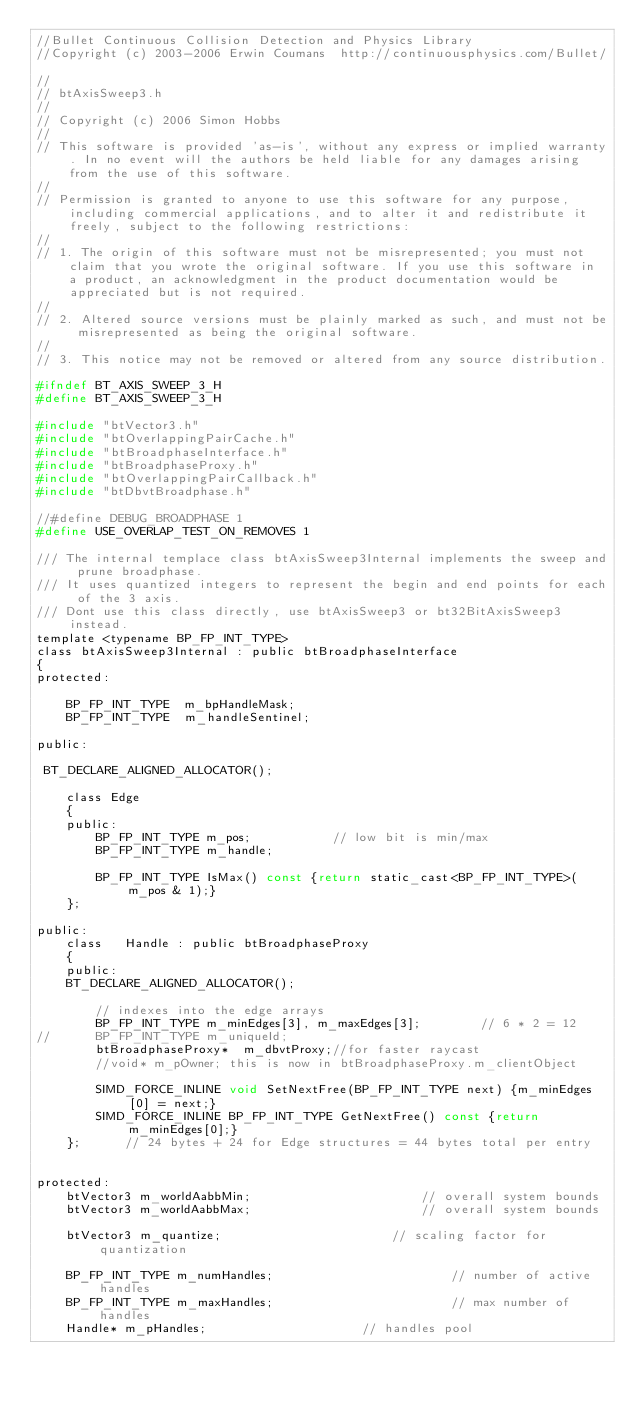<code> <loc_0><loc_0><loc_500><loc_500><_C_>//Bullet Continuous Collision Detection and Physics Library
//Copyright (c) 2003-2006 Erwin Coumans  http://continuousphysics.com/Bullet/

//
// btAxisSweep3.h
//
// Copyright (c) 2006 Simon Hobbs
//
// This software is provided 'as-is', without any express or implied warranty. In no event will the authors be held liable for any damages arising from the use of this software.
//
// Permission is granted to anyone to use this software for any purpose, including commercial applications, and to alter it and redistribute it freely, subject to the following restrictions:
//
// 1. The origin of this software must not be misrepresented; you must not claim that you wrote the original software. If you use this software in a product, an acknowledgment in the product documentation would be appreciated but is not required.
//
// 2. Altered source versions must be plainly marked as such, and must not be misrepresented as being the original software.
//
// 3. This notice may not be removed or altered from any source distribution.

#ifndef BT_AXIS_SWEEP_3_H
#define BT_AXIS_SWEEP_3_H

#include "btVector3.h"
#include "btOverlappingPairCache.h"
#include "btBroadphaseInterface.h"
#include "btBroadphaseProxy.h"
#include "btOverlappingPairCallback.h"
#include "btDbvtBroadphase.h"

//#define DEBUG_BROADPHASE 1
#define USE_OVERLAP_TEST_ON_REMOVES 1

/// The internal templace class btAxisSweep3Internal implements the sweep and prune broadphase.
/// It uses quantized integers to represent the begin and end points for each of the 3 axis.
/// Dont use this class directly, use btAxisSweep3 or bt32BitAxisSweep3 instead.
template <typename BP_FP_INT_TYPE>
class btAxisSweep3Internal : public btBroadphaseInterface
{
protected:

	BP_FP_INT_TYPE	m_bpHandleMask;
	BP_FP_INT_TYPE	m_handleSentinel;

public:
	
 BT_DECLARE_ALIGNED_ALLOCATOR();

	class Edge
	{
	public:
		BP_FP_INT_TYPE m_pos;			// low bit is min/max
		BP_FP_INT_TYPE m_handle;

		BP_FP_INT_TYPE IsMax() const {return static_cast<BP_FP_INT_TYPE>(m_pos & 1);}
	};

public:
	class	Handle : public btBroadphaseProxy
	{
	public:
	BT_DECLARE_ALIGNED_ALLOCATOR();
	
		// indexes into the edge arrays
		BP_FP_INT_TYPE m_minEdges[3], m_maxEdges[3];		// 6 * 2 = 12
//		BP_FP_INT_TYPE m_uniqueId;
		btBroadphaseProxy*	m_dbvtProxy;//for faster raycast
		//void* m_pOwner; this is now in btBroadphaseProxy.m_clientObject
	
		SIMD_FORCE_INLINE void SetNextFree(BP_FP_INT_TYPE next) {m_minEdges[0] = next;}
		SIMD_FORCE_INLINE BP_FP_INT_TYPE GetNextFree() const {return m_minEdges[0];}
	};		// 24 bytes + 24 for Edge structures = 44 bytes total per entry

	
protected:
	btVector3 m_worldAabbMin;						// overall system bounds
	btVector3 m_worldAabbMax;						// overall system bounds

	btVector3 m_quantize;						// scaling factor for quantization

	BP_FP_INT_TYPE m_numHandles;						// number of active handles
	BP_FP_INT_TYPE m_maxHandles;						// max number of handles
	Handle* m_pHandles;						// handles pool
	</code> 